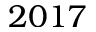Convert formula to latex. <formula><loc_0><loc_0><loc_500><loc_500>2 0 1 7</formula> 